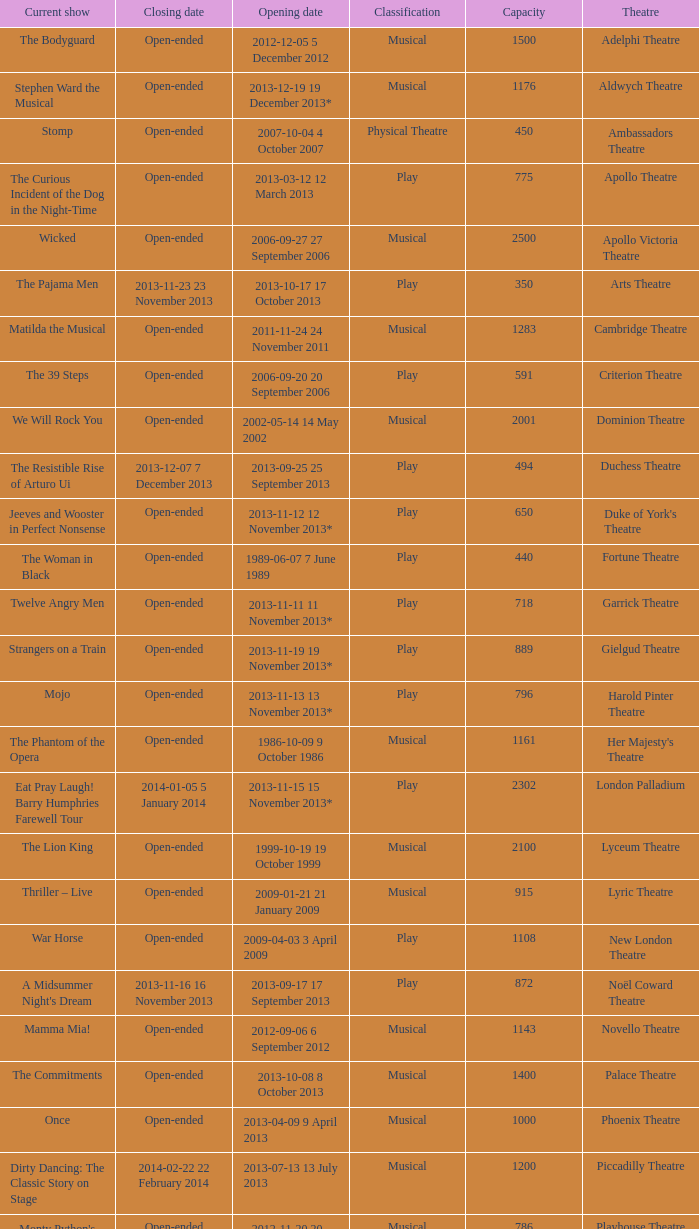What is the opening date of the musical at the adelphi theatre? 2012-12-05 5 December 2012. 